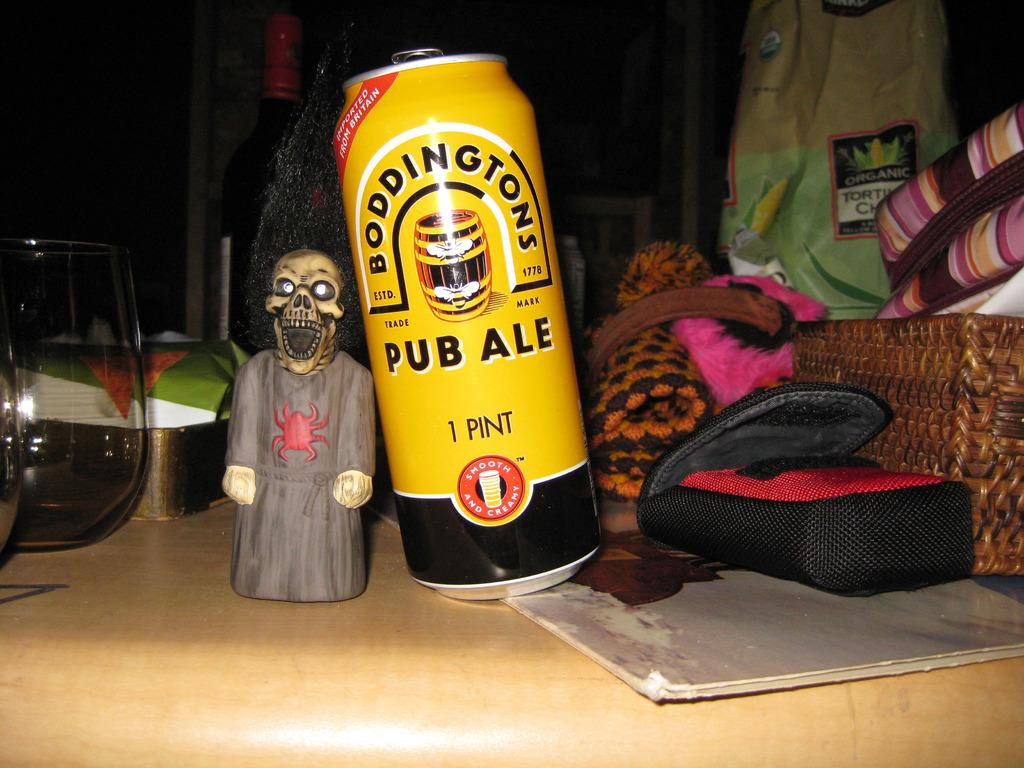What type of beverage container is on the table in the image? There is a coke can on the table. What else can be seen on the table besides the coke can? There are big glasses, a toy, and a basket on the table. What is the purpose of the basket on the table? The basket on the table is used to hold objects. Can you describe the contents of the basket on the right side of the image? The basket on the right side of the image contains bags and other objects. What type of competition is taking place in the image? There is no competition present in the image; it features a table with various objects on it. Where is the cellar located in the image? There is no cellar present in the image. 